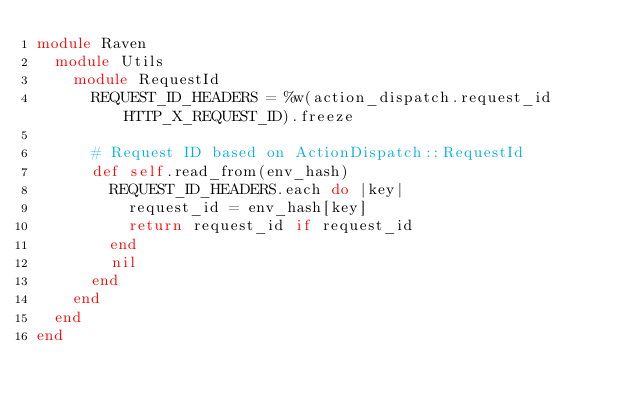Convert code to text. <code><loc_0><loc_0><loc_500><loc_500><_Ruby_>module Raven
  module Utils
    module RequestId
      REQUEST_ID_HEADERS = %w(action_dispatch.request_id HTTP_X_REQUEST_ID).freeze

      # Request ID based on ActionDispatch::RequestId
      def self.read_from(env_hash)
        REQUEST_ID_HEADERS.each do |key|
          request_id = env_hash[key]
          return request_id if request_id
        end
        nil
      end
    end
  end
end
</code> 